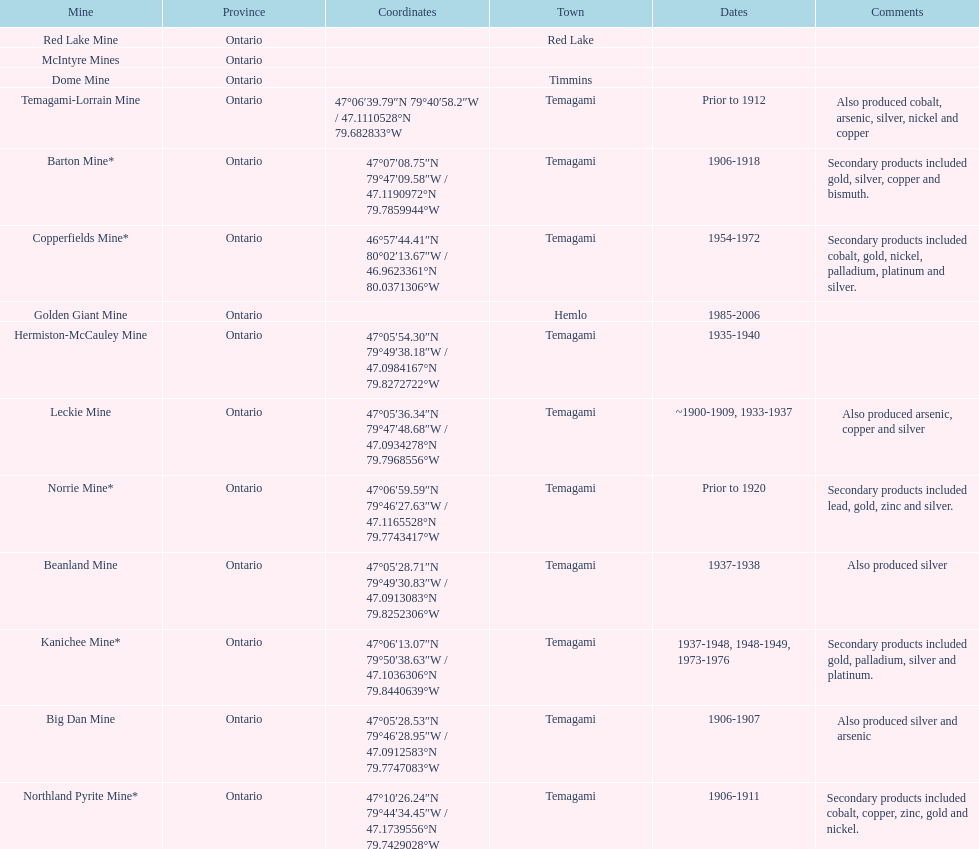In what mine could you find bismuth? Barton Mine. 